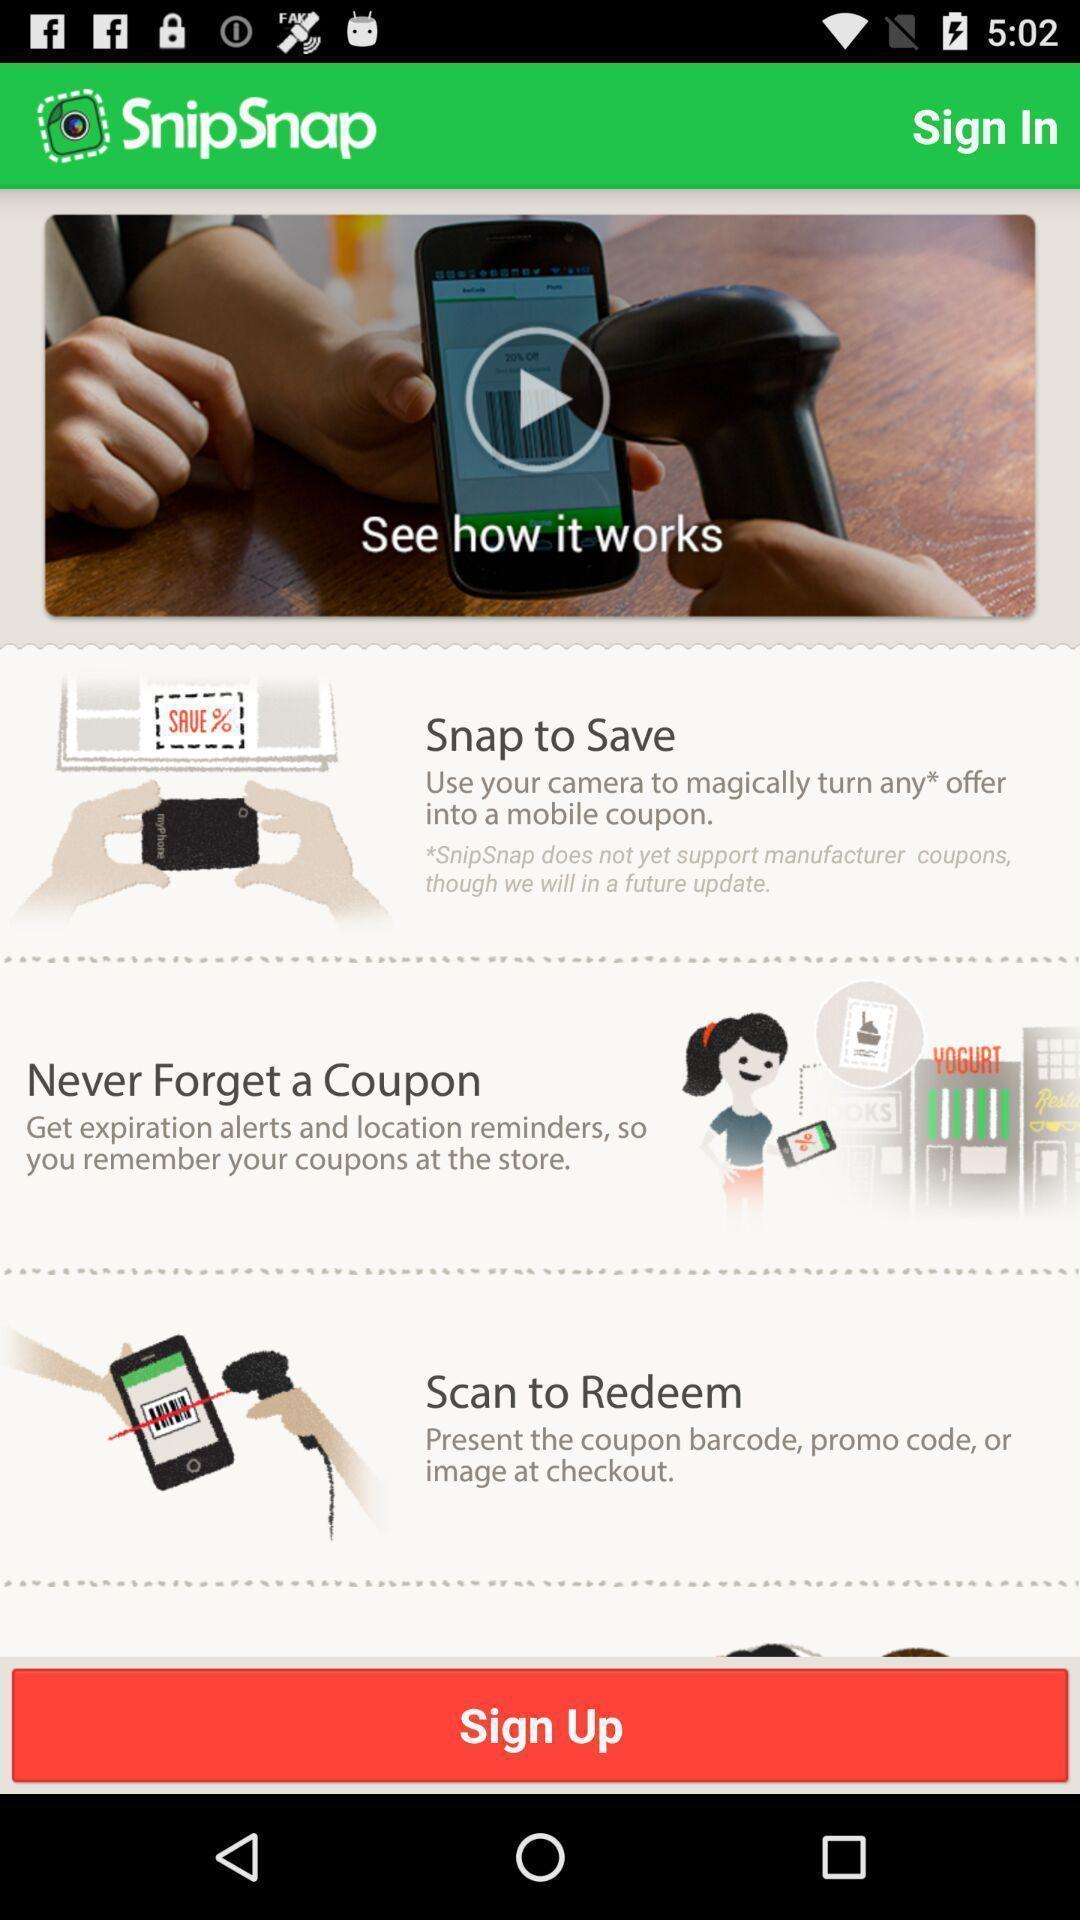Give me a summary of this screen capture. Sign up page. 